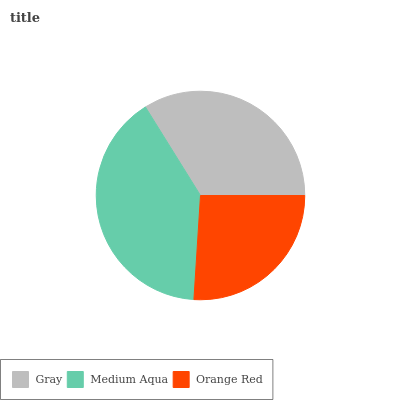Is Orange Red the minimum?
Answer yes or no. Yes. Is Medium Aqua the maximum?
Answer yes or no. Yes. Is Medium Aqua the minimum?
Answer yes or no. No. Is Orange Red the maximum?
Answer yes or no. No. Is Medium Aqua greater than Orange Red?
Answer yes or no. Yes. Is Orange Red less than Medium Aqua?
Answer yes or no. Yes. Is Orange Red greater than Medium Aqua?
Answer yes or no. No. Is Medium Aqua less than Orange Red?
Answer yes or no. No. Is Gray the high median?
Answer yes or no. Yes. Is Gray the low median?
Answer yes or no. Yes. Is Orange Red the high median?
Answer yes or no. No. Is Medium Aqua the low median?
Answer yes or no. No. 